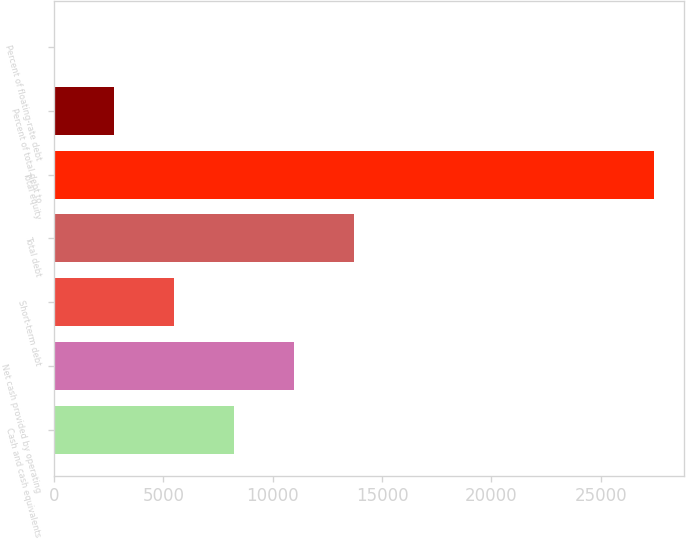Convert chart. <chart><loc_0><loc_0><loc_500><loc_500><bar_chart><fcel>Cash and cash equivalents<fcel>Net cash provided by operating<fcel>Short-term debt<fcel>Total debt<fcel>Total equity<fcel>Percent of total debt to<fcel>Percent of floating-rate debt<nl><fcel>8236.1<fcel>10977.8<fcel>5494.4<fcel>13719.5<fcel>27428<fcel>2752.7<fcel>11<nl></chart> 